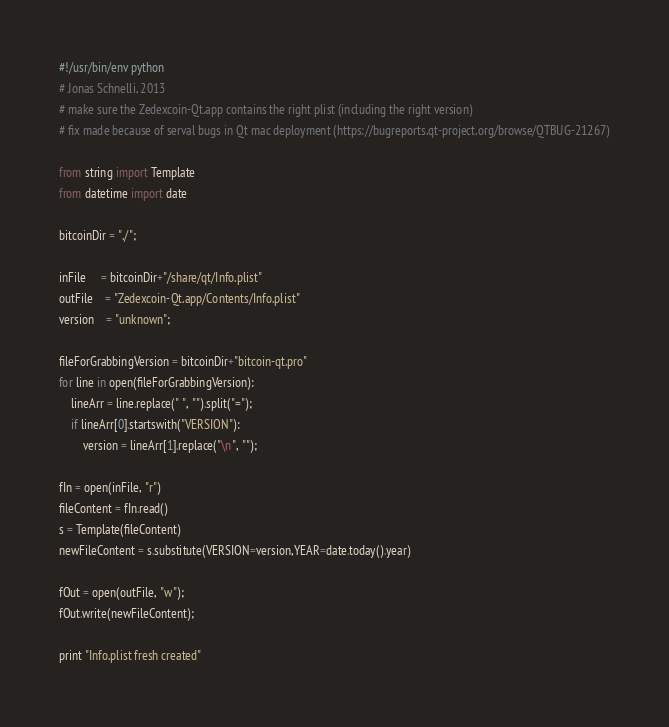Convert code to text. <code><loc_0><loc_0><loc_500><loc_500><_Python_>#!/usr/bin/env python
# Jonas Schnelli, 2013
# make sure the Zedexcoin-Qt.app contains the right plist (including the right version)
# fix made because of serval bugs in Qt mac deployment (https://bugreports.qt-project.org/browse/QTBUG-21267)

from string import Template
from datetime import date

bitcoinDir = "./";

inFile     = bitcoinDir+"/share/qt/Info.plist"
outFile    = "Zedexcoin-Qt.app/Contents/Info.plist"
version    = "unknown";

fileForGrabbingVersion = bitcoinDir+"bitcoin-qt.pro"
for line in open(fileForGrabbingVersion):
	lineArr = line.replace(" ", "").split("=");
	if lineArr[0].startswith("VERSION"):
		version = lineArr[1].replace("\n", "");

fIn = open(inFile, "r")
fileContent = fIn.read()
s = Template(fileContent)
newFileContent = s.substitute(VERSION=version,YEAR=date.today().year)

fOut = open(outFile, "w");
fOut.write(newFileContent);

print "Info.plist fresh created"
</code> 